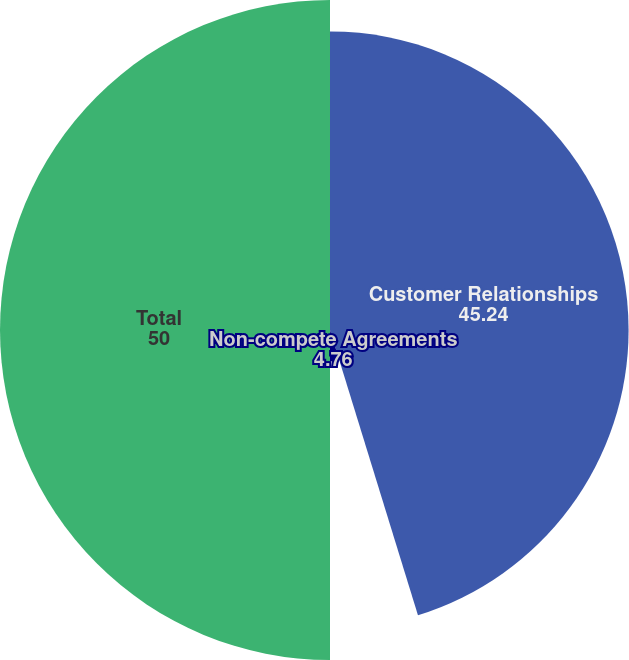Convert chart. <chart><loc_0><loc_0><loc_500><loc_500><pie_chart><fcel>Customer Relationships<fcel>Non-compete Agreements<fcel>Total<nl><fcel>45.24%<fcel>4.76%<fcel>50.0%<nl></chart> 